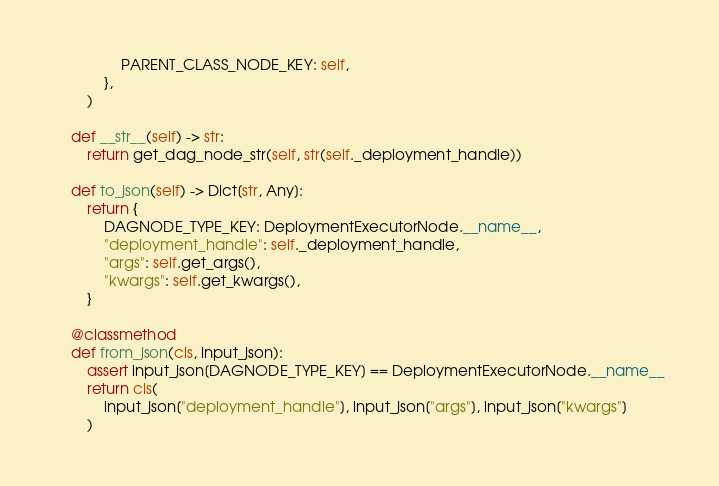<code> <loc_0><loc_0><loc_500><loc_500><_Python_>                PARENT_CLASS_NODE_KEY: self,
            },
        )

    def __str__(self) -> str:
        return get_dag_node_str(self, str(self._deployment_handle))

    def to_json(self) -> Dict[str, Any]:
        return {
            DAGNODE_TYPE_KEY: DeploymentExecutorNode.__name__,
            "deployment_handle": self._deployment_handle,
            "args": self.get_args(),
            "kwargs": self.get_kwargs(),
        }

    @classmethod
    def from_json(cls, input_json):
        assert input_json[DAGNODE_TYPE_KEY] == DeploymentExecutorNode.__name__
        return cls(
            input_json["deployment_handle"], input_json["args"], input_json["kwargs"]
        )
</code> 